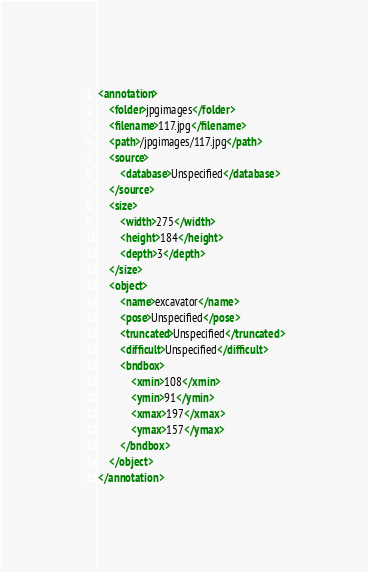<code> <loc_0><loc_0><loc_500><loc_500><_XML_><annotation>
	<folder>jpgimages</folder>
	<filename>117.jpg</filename>
	<path>/jpgimages/117.jpg</path>
	<source>
		<database>Unspecified</database>
	</source>
	<size>
		<width>275</width>
		<height>184</height>
		<depth>3</depth>
	</size>
	<object>
		<name>excavator</name>
		<pose>Unspecified</pose>
		<truncated>Unspecified</truncated>
		<difficult>Unspecified</difficult>
		<bndbox>
			<xmin>108</xmin>
			<ymin>91</ymin>
			<xmax>197</xmax>
			<ymax>157</ymax>
		</bndbox>
	</object>
</annotation></code> 